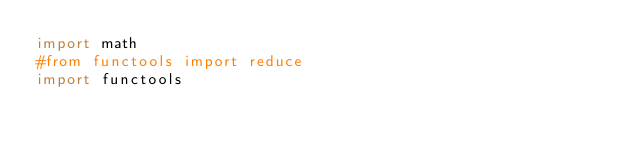Convert code to text. <code><loc_0><loc_0><loc_500><loc_500><_Python_>import math
#from functools import reduce
import functools</code> 